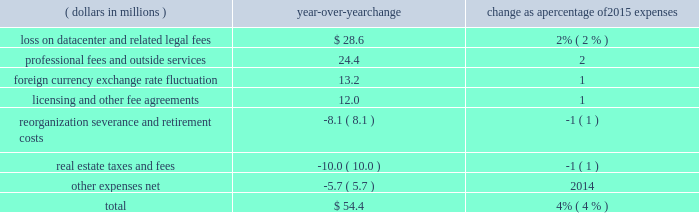Recognized total losses and expenses of $ 28.6 million , including a net loss on write-down to fair value of the assets and certain other transaction fees of $ 27.1 million within other expenses and $ 1.5 million of legal and other fees .
2022 professional fees and outside services expense decreased in 2017 compared to 2016 , largely due to higher legal and regulatory fees in 2016 related to our business activities and product offerings as well as higher professional fees related to a greater reliance on consultants for security and systems enhancement work .
The overall decrease in operating expenses in 2017 when compared with 2016 was partially offset by the following increases : 2022 licensing and other fee sharing agreements expense increased due to higher expense resulting from incentive payments made to facilitate the transition of the russell contract open interest , as well as increased costs of revenue sharing agreements for certain licensed products .
The overall increase in 2017 was partially offset by lower expense related to revenue sharing agreements for certain equity and energy contracts due to lower volume for these products compared to 2016 .
2022 compensation and benefits expense increased as a result of higher average headcount primarily in our international locations as well as normal cost of living adjustments .
2016 compared with 2015 operating expenses increased by $ 54.4 million in 2016 when compared with 2015 .
The table shows the estimated impact of key factors resulting in the net decrease in operating expenses .
( dollars in millions ) over-year change change as a percentage of 2015 expenses .
Overall operating expenses increased in 2016 when compared with 2015 due to the following reasons : 2022 in 2016 , we recognized total losses and expenses of $ 28.6 million , including a net loss on write-down to fair value of the assets and certain other transaction fees of $ 27.1 million within other expenses and $ 1.5 million of legal and other fees as a result of our sale and leaseback of our datacenter .
2022 professional fees and outside services expense increased in 2016 largely due to an increase in legal and regulatory efforts related to our business activities and product offerings as well as an increase in professional fees related to a greater reliance on consultants for security and systems enhancement work .
2022 in 2016 , we recognized a net loss of $ 24.5 million due to an unfavorable change in exchange rates on foreign cash balances , compared with a net loss of $ 11.3 million in 2015 .
2022 licensing and other fee sharing agreements expense increased due to higher expense related to revenue sharing agreements for certain equity and energy contracts due to both higher volume and an increase in license rates for certain equity and energy products. .
What was the loss on datacenter and related legal fees in 2015 in millions dollars? 
Rationale: considering that $ 28.6 millions represents a 2% increase in the loss on datacenter and related legal fees of 2015 , the original value is calculated dividing the increase of $ 28.6 by its the percentage .
Computations: (28.6 / 2%)
Answer: 1430.0. 